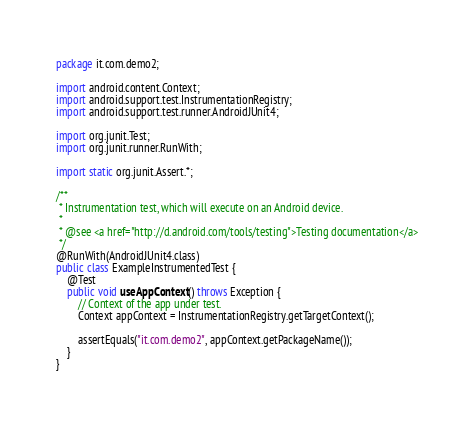Convert code to text. <code><loc_0><loc_0><loc_500><loc_500><_Java_>package it.com.demo2;

import android.content.Context;
import android.support.test.InstrumentationRegistry;
import android.support.test.runner.AndroidJUnit4;

import org.junit.Test;
import org.junit.runner.RunWith;

import static org.junit.Assert.*;

/**
 * Instrumentation test, which will execute on an Android device.
 *
 * @see <a href="http://d.android.com/tools/testing">Testing documentation</a>
 */
@RunWith(AndroidJUnit4.class)
public class ExampleInstrumentedTest {
    @Test
    public void useAppContext() throws Exception {
        // Context of the app under test.
        Context appContext = InstrumentationRegistry.getTargetContext();

        assertEquals("it.com.demo2", appContext.getPackageName());
    }
}
</code> 